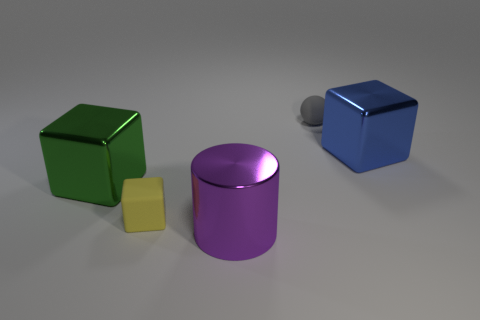There is a metallic block that is in front of the big blue metal object; what number of large shiny blocks are on the left side of it?
Offer a very short reply. 0. Are there any other things that are the same color as the rubber ball?
Your response must be concise. No. How many things are large yellow balls or things in front of the gray matte object?
Provide a short and direct response. 4. What is the small thing in front of the block behind the big metallic cube to the left of the metallic cylinder made of?
Give a very brief answer. Rubber. There is a yellow block that is the same material as the gray object; what size is it?
Keep it short and to the point. Small. What color is the matte object that is left of the tiny thing behind the large green cube?
Offer a very short reply. Yellow. How many green objects are the same material as the blue object?
Make the answer very short. 1. How many matte things are blue objects or green things?
Give a very brief answer. 0. What material is the blue block that is the same size as the cylinder?
Ensure brevity in your answer.  Metal. Are there any large blocks that have the same material as the tiny sphere?
Ensure brevity in your answer.  No. 